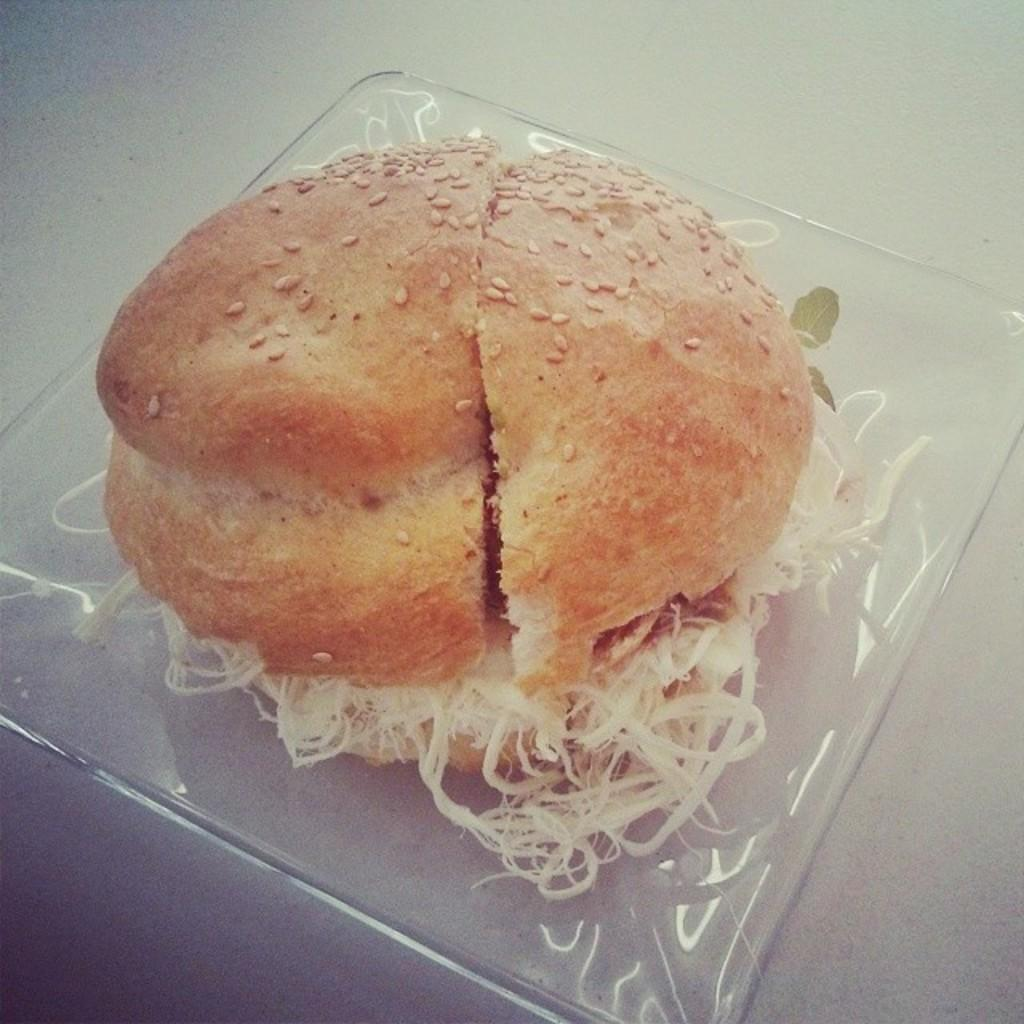What type of food is shown in the image? There is a burger in the image. How many clocks are visible on the burger in the image? There are no clocks visible on the burger in the image. What type of wrist is shown holding the burger in the image? There is no wrist shown holding the burger in the image. 